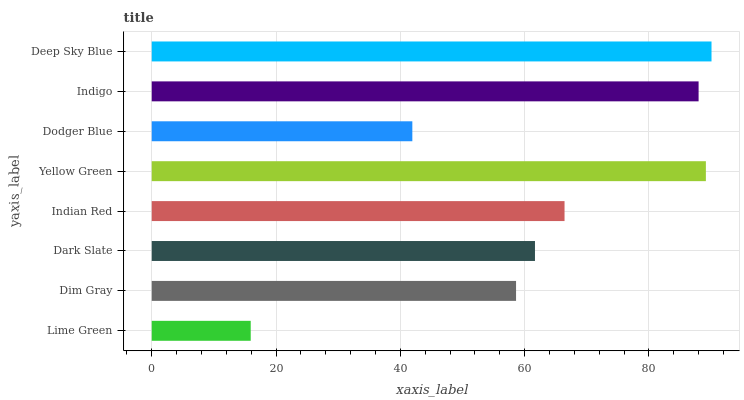Is Lime Green the minimum?
Answer yes or no. Yes. Is Deep Sky Blue the maximum?
Answer yes or no. Yes. Is Dim Gray the minimum?
Answer yes or no. No. Is Dim Gray the maximum?
Answer yes or no. No. Is Dim Gray greater than Lime Green?
Answer yes or no. Yes. Is Lime Green less than Dim Gray?
Answer yes or no. Yes. Is Lime Green greater than Dim Gray?
Answer yes or no. No. Is Dim Gray less than Lime Green?
Answer yes or no. No. Is Indian Red the high median?
Answer yes or no. Yes. Is Dark Slate the low median?
Answer yes or no. Yes. Is Deep Sky Blue the high median?
Answer yes or no. No. Is Indian Red the low median?
Answer yes or no. No. 